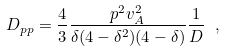<formula> <loc_0><loc_0><loc_500><loc_500>D _ { p p } = \frac { 4 } { 3 } \frac { p ^ { 2 } v _ { A } ^ { 2 } } { \delta ( 4 - \delta ^ { 2 } ) ( 4 - \delta ) } \frac { 1 } { D } \ ,</formula> 